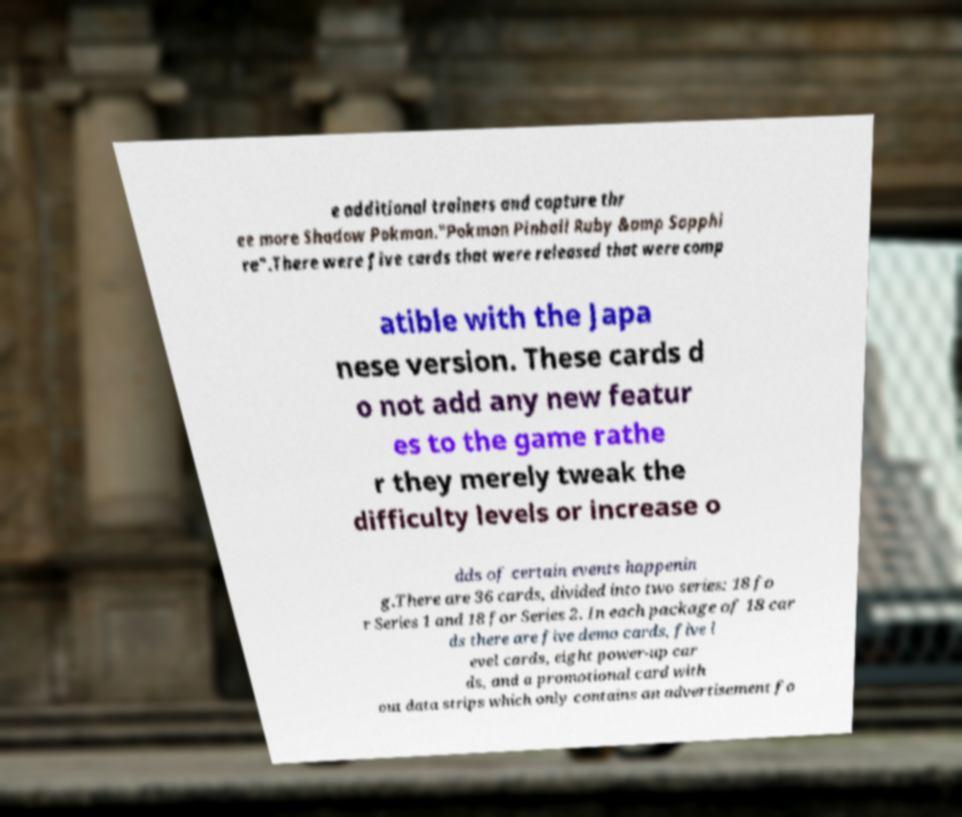Can you accurately transcribe the text from the provided image for me? e additional trainers and capture thr ee more Shadow Pokmon."Pokmon Pinball Ruby &amp Sapphi re".There were five cards that were released that were comp atible with the Japa nese version. These cards d o not add any new featur es to the game rathe r they merely tweak the difficulty levels or increase o dds of certain events happenin g.There are 36 cards, divided into two series: 18 fo r Series 1 and 18 for Series 2. In each package of 18 car ds there are five demo cards, five l evel cards, eight power-up car ds, and a promotional card with out data strips which only contains an advertisement fo 